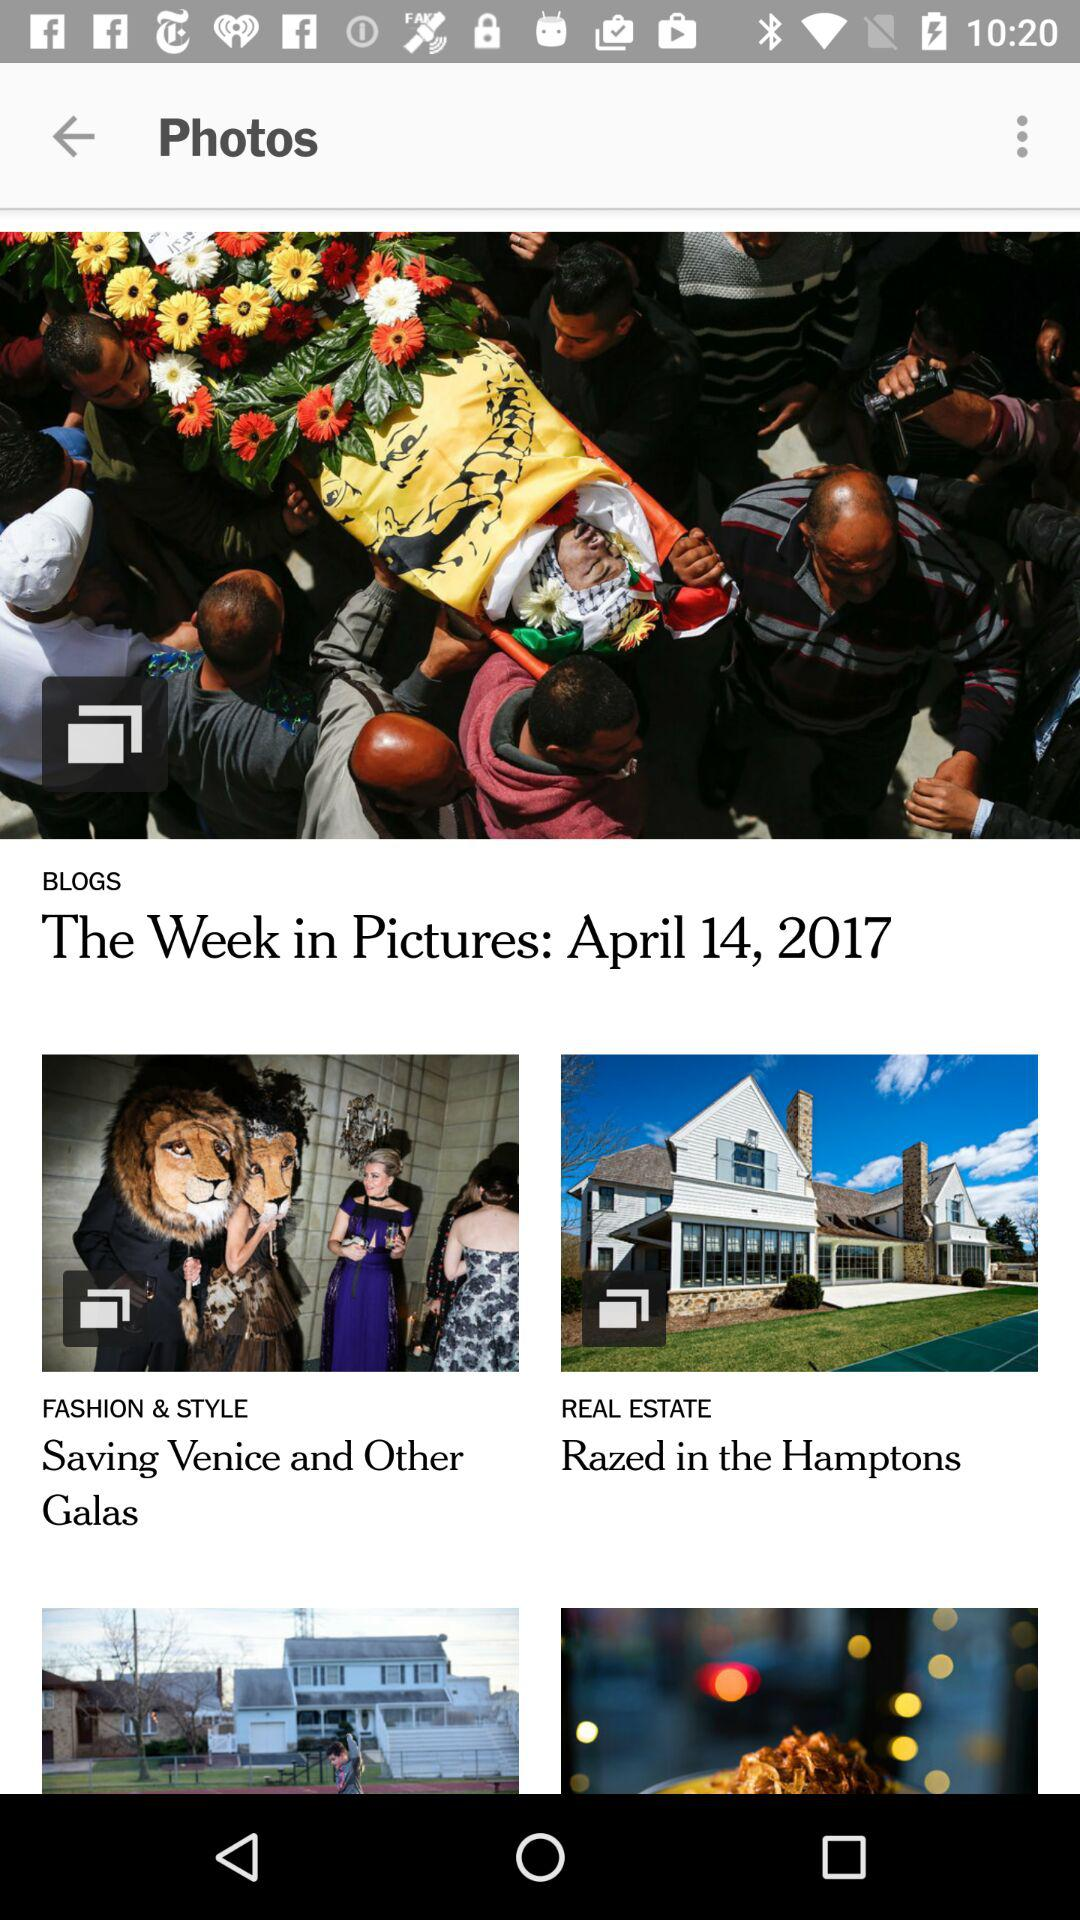What is the name of the blog posted on April 14, 2017? The name of the blog is "The Week in Pictures". 